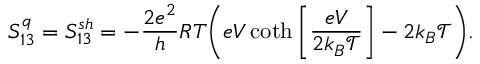<formula> <loc_0><loc_0><loc_500><loc_500>S _ { 1 3 } ^ { q } = { S _ { 1 3 } ^ { s h } } = - \frac { 2 e ^ { 2 } } { h } R T \left ( e V \coth \left [ \frac { e V } { 2 k _ { B } \mathcal { T } } \right ] - 2 k _ { B } \mathcal { T } \right ) .</formula> 